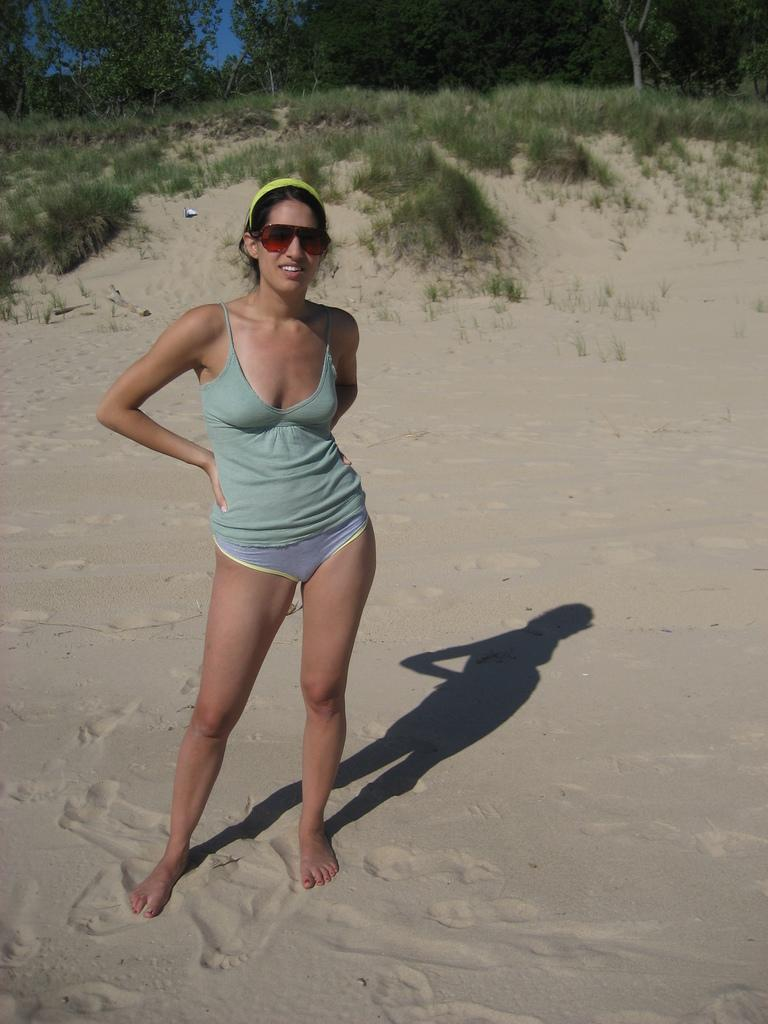What is the main subject of the image? The main subject of the image is a woman. What is the woman wearing? The woman is wearing clothes and a Google product, possibly glasses or a smartwatch. What is the ground like in the image? The ground is sandy. What type of vegetation can be seen in the image? There is grass and trees in the image. What part of the natural environment is visible in the image? The sky is visible in the image. What accessory is the woman wearing in her hair? The woman is wearing a hair belt. What type of slope can be seen in the image? There is no slope present in the image. Is there a party happening in the image? There is no indication of a party in the image. 